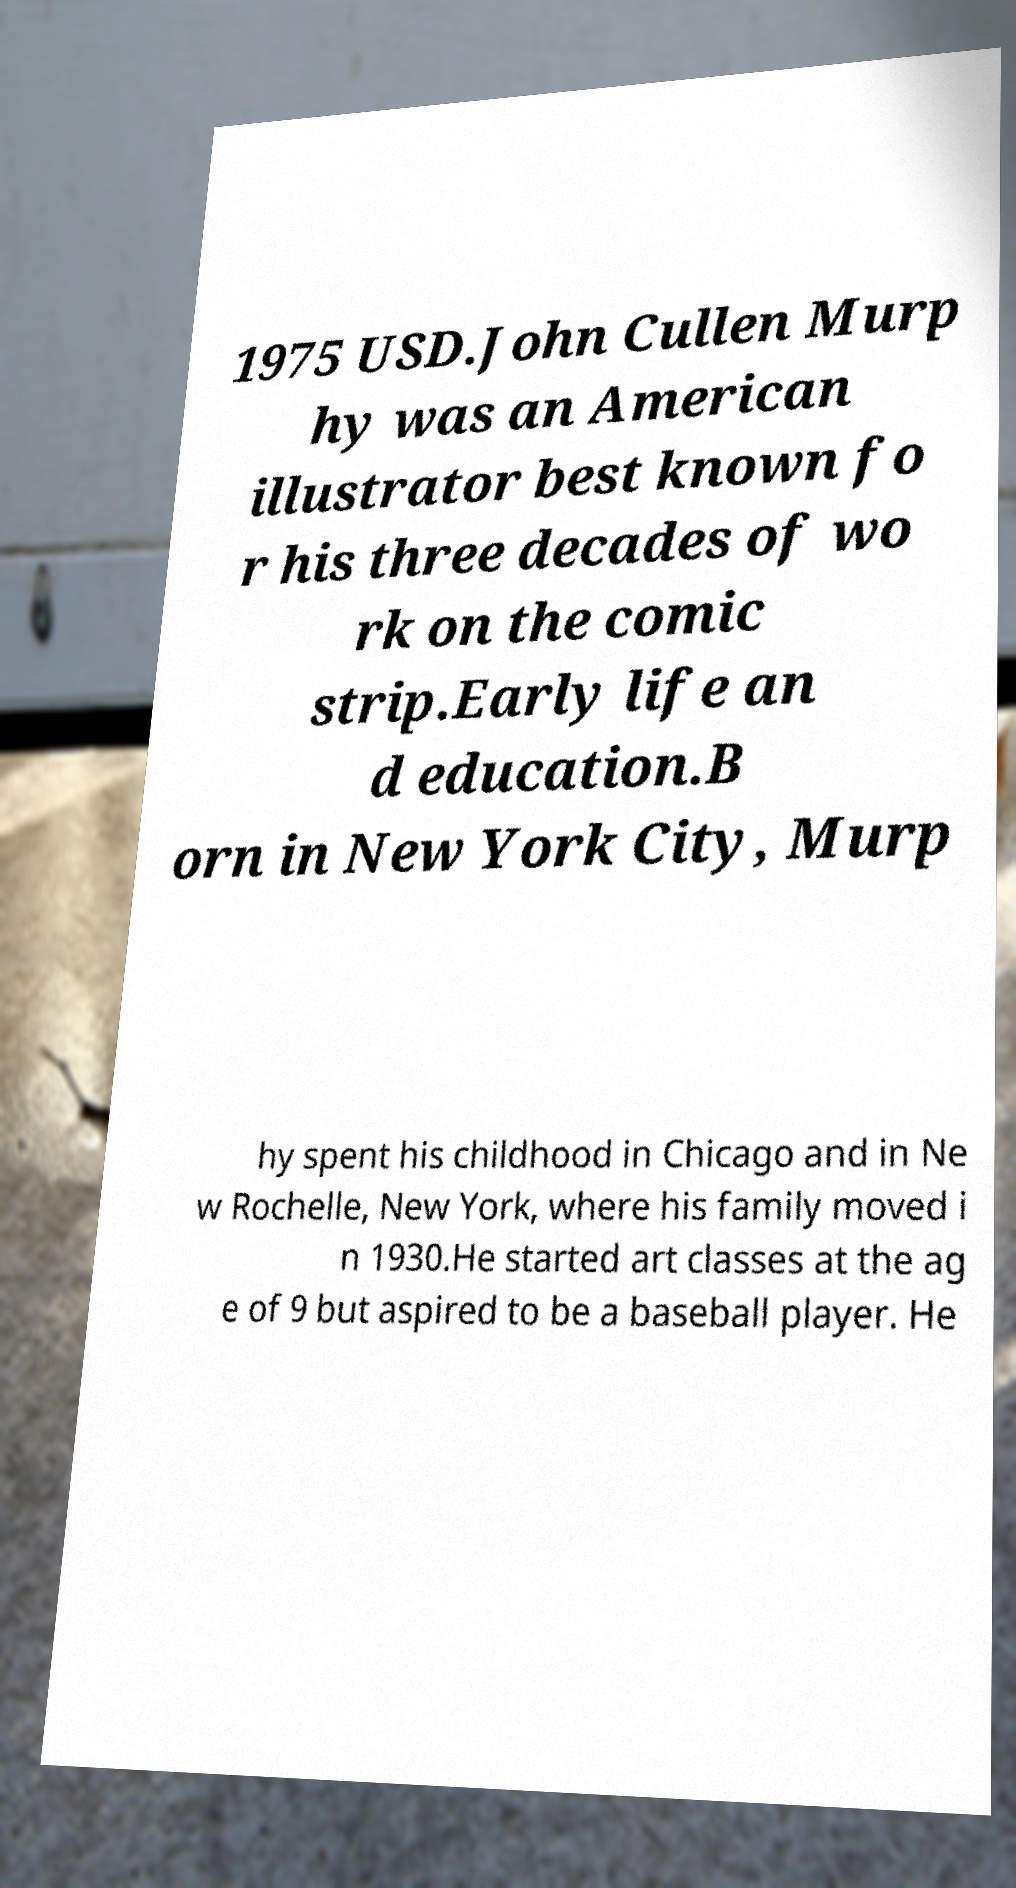Can you read and provide the text displayed in the image?This photo seems to have some interesting text. Can you extract and type it out for me? 1975 USD.John Cullen Murp hy was an American illustrator best known fo r his three decades of wo rk on the comic strip.Early life an d education.B orn in New York City, Murp hy spent his childhood in Chicago and in Ne w Rochelle, New York, where his family moved i n 1930.He started art classes at the ag e of 9 but aspired to be a baseball player. He 